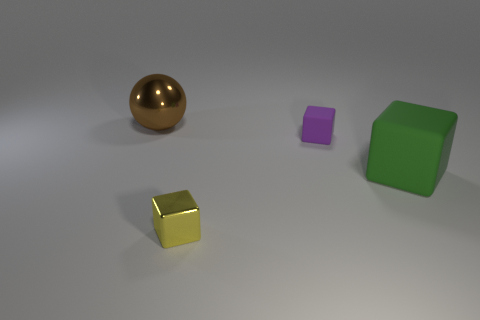Is the shape of the green matte object the same as the purple object?
Make the answer very short. Yes. What number of balls are matte things or big green matte objects?
Keep it short and to the point. 0. There is a thing that is made of the same material as the small purple cube; what color is it?
Give a very brief answer. Green. There is a rubber cube that is behind the green rubber cube; does it have the same size as the brown thing?
Provide a short and direct response. No. Are the yellow cube and the tiny block to the right of the yellow thing made of the same material?
Offer a very short reply. No. The large thing that is behind the big matte block is what color?
Your answer should be compact. Brown. Are there any big brown spheres that are behind the small object that is to the right of the small metallic block?
Keep it short and to the point. Yes. Do the matte thing right of the purple thing and the cube that is behind the green matte thing have the same color?
Give a very brief answer. No. How many big green matte objects are to the left of the large brown sphere?
Your answer should be compact. 0. How many large shiny things are the same color as the tiny shiny cube?
Offer a very short reply. 0. 